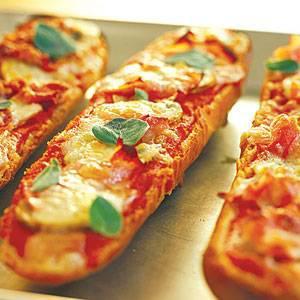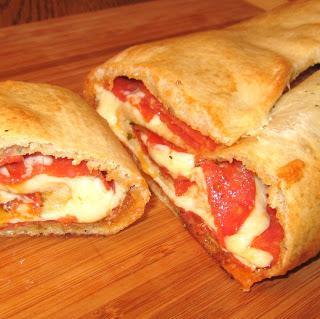The first image is the image on the left, the second image is the image on the right. For the images displayed, is the sentence "In at least one image there is pepperoni pizza bread with marinara sauce to the left of the bread." factually correct? Answer yes or no. No. The first image is the image on the left, the second image is the image on the right. For the images displayed, is the sentence "The right image shows an oblong loaf with pepperoni sticking out of criss-cross cuts, and the left image includes at least one rectangular shape with pepperonis and melted cheese on top." factually correct? Answer yes or no. No. 